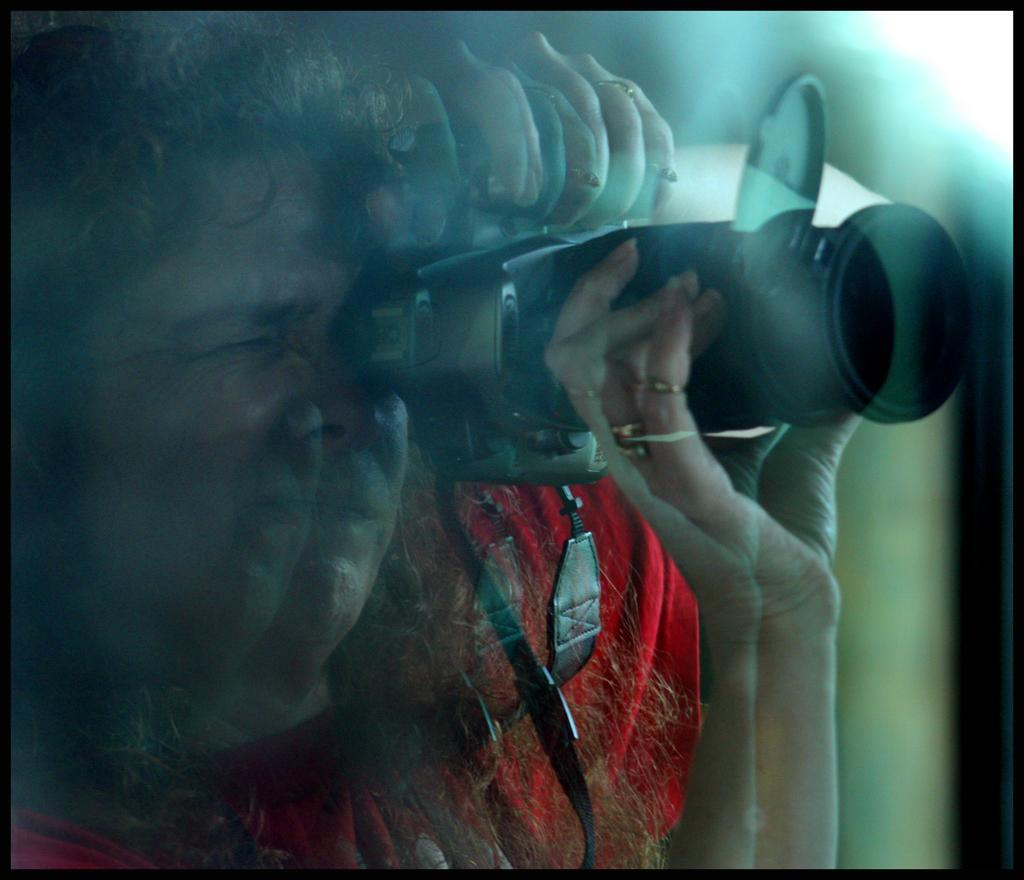What is the main subject of the image? There is a person in the image. What is the person holding in the image? The person is holding a camera. What is the person about to do with the camera? The person is about to click pictures with the camera. What type of zipper can be seen on the person's clothing in the image? There is no zipper visible on the person's clothing in the image. Is there a volleyball game happening in the background of the image? There is no volleyball game or any reference to volleyball in the image. 